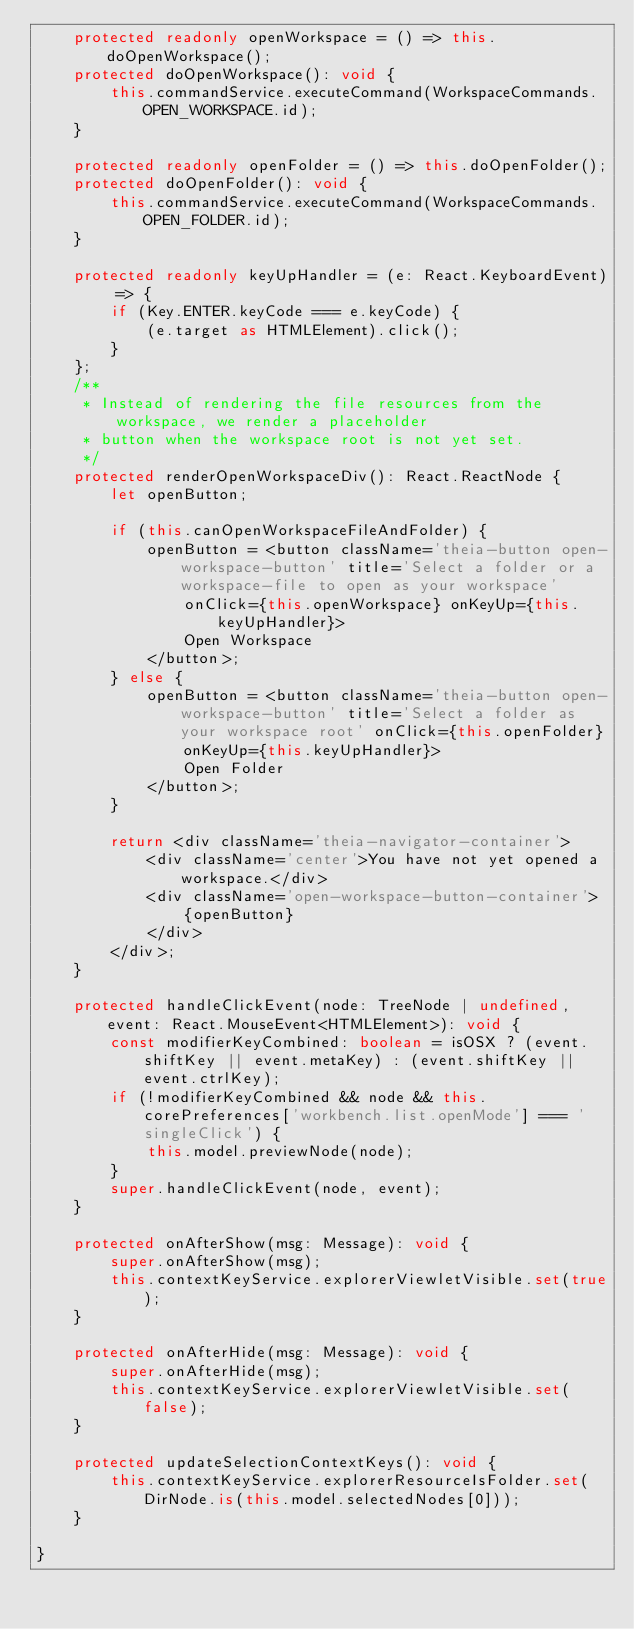Convert code to text. <code><loc_0><loc_0><loc_500><loc_500><_TypeScript_>    protected readonly openWorkspace = () => this.doOpenWorkspace();
    protected doOpenWorkspace(): void {
        this.commandService.executeCommand(WorkspaceCommands.OPEN_WORKSPACE.id);
    }

    protected readonly openFolder = () => this.doOpenFolder();
    protected doOpenFolder(): void {
        this.commandService.executeCommand(WorkspaceCommands.OPEN_FOLDER.id);
    }

    protected readonly keyUpHandler = (e: React.KeyboardEvent) => {
        if (Key.ENTER.keyCode === e.keyCode) {
            (e.target as HTMLElement).click();
        }
    };
    /**
     * Instead of rendering the file resources from the workspace, we render a placeholder
     * button when the workspace root is not yet set.
     */
    protected renderOpenWorkspaceDiv(): React.ReactNode {
        let openButton;

        if (this.canOpenWorkspaceFileAndFolder) {
            openButton = <button className='theia-button open-workspace-button' title='Select a folder or a workspace-file to open as your workspace'
                onClick={this.openWorkspace} onKeyUp={this.keyUpHandler}>
                Open Workspace
            </button>;
        } else {
            openButton = <button className='theia-button open-workspace-button' title='Select a folder as your workspace root' onClick={this.openFolder}
                onKeyUp={this.keyUpHandler}>
                Open Folder
            </button>;
        }

        return <div className='theia-navigator-container'>
            <div className='center'>You have not yet opened a workspace.</div>
            <div className='open-workspace-button-container'>
                {openButton}
            </div>
        </div>;
    }

    protected handleClickEvent(node: TreeNode | undefined, event: React.MouseEvent<HTMLElement>): void {
        const modifierKeyCombined: boolean = isOSX ? (event.shiftKey || event.metaKey) : (event.shiftKey || event.ctrlKey);
        if (!modifierKeyCombined && node && this.corePreferences['workbench.list.openMode'] === 'singleClick') {
            this.model.previewNode(node);
        }
        super.handleClickEvent(node, event);
    }

    protected onAfterShow(msg: Message): void {
        super.onAfterShow(msg);
        this.contextKeyService.explorerViewletVisible.set(true);
    }

    protected onAfterHide(msg: Message): void {
        super.onAfterHide(msg);
        this.contextKeyService.explorerViewletVisible.set(false);
    }

    protected updateSelectionContextKeys(): void {
        this.contextKeyService.explorerResourceIsFolder.set(DirNode.is(this.model.selectedNodes[0]));
    }

}
</code> 